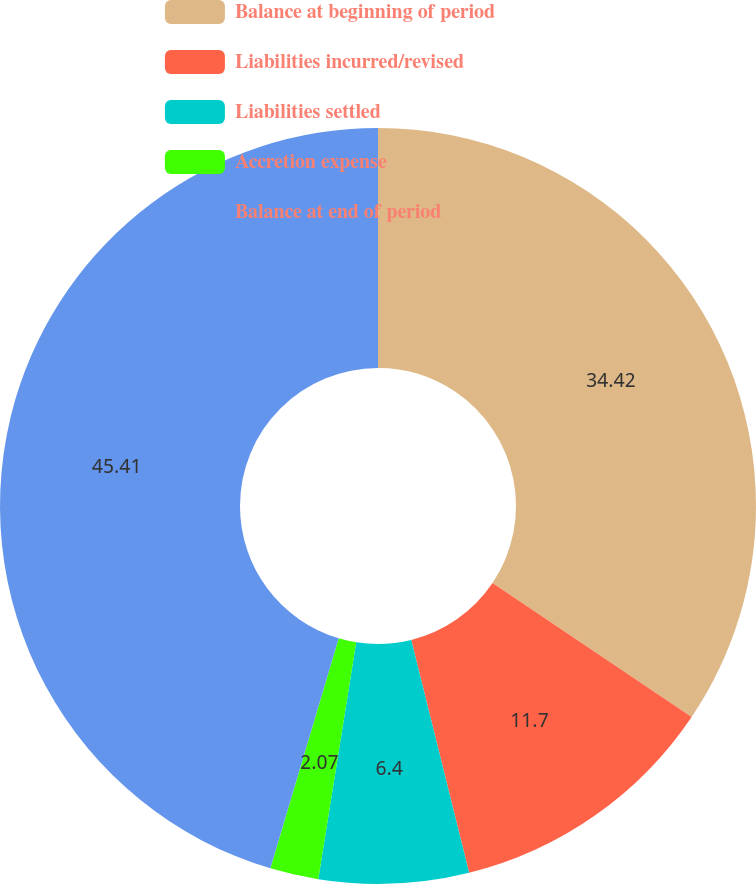<chart> <loc_0><loc_0><loc_500><loc_500><pie_chart><fcel>Balance at beginning of period<fcel>Liabilities incurred/revised<fcel>Liabilities settled<fcel>Accretion expense<fcel>Balance at end of period<nl><fcel>34.42%<fcel>11.7%<fcel>6.4%<fcel>2.07%<fcel>45.4%<nl></chart> 